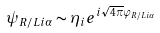Convert formula to latex. <formula><loc_0><loc_0><loc_500><loc_500>\psi _ { R / L i \alpha } \sim \eta _ { i } e ^ { i \sqrt { 4 \pi } \varphi _ { R / L i \alpha } }</formula> 